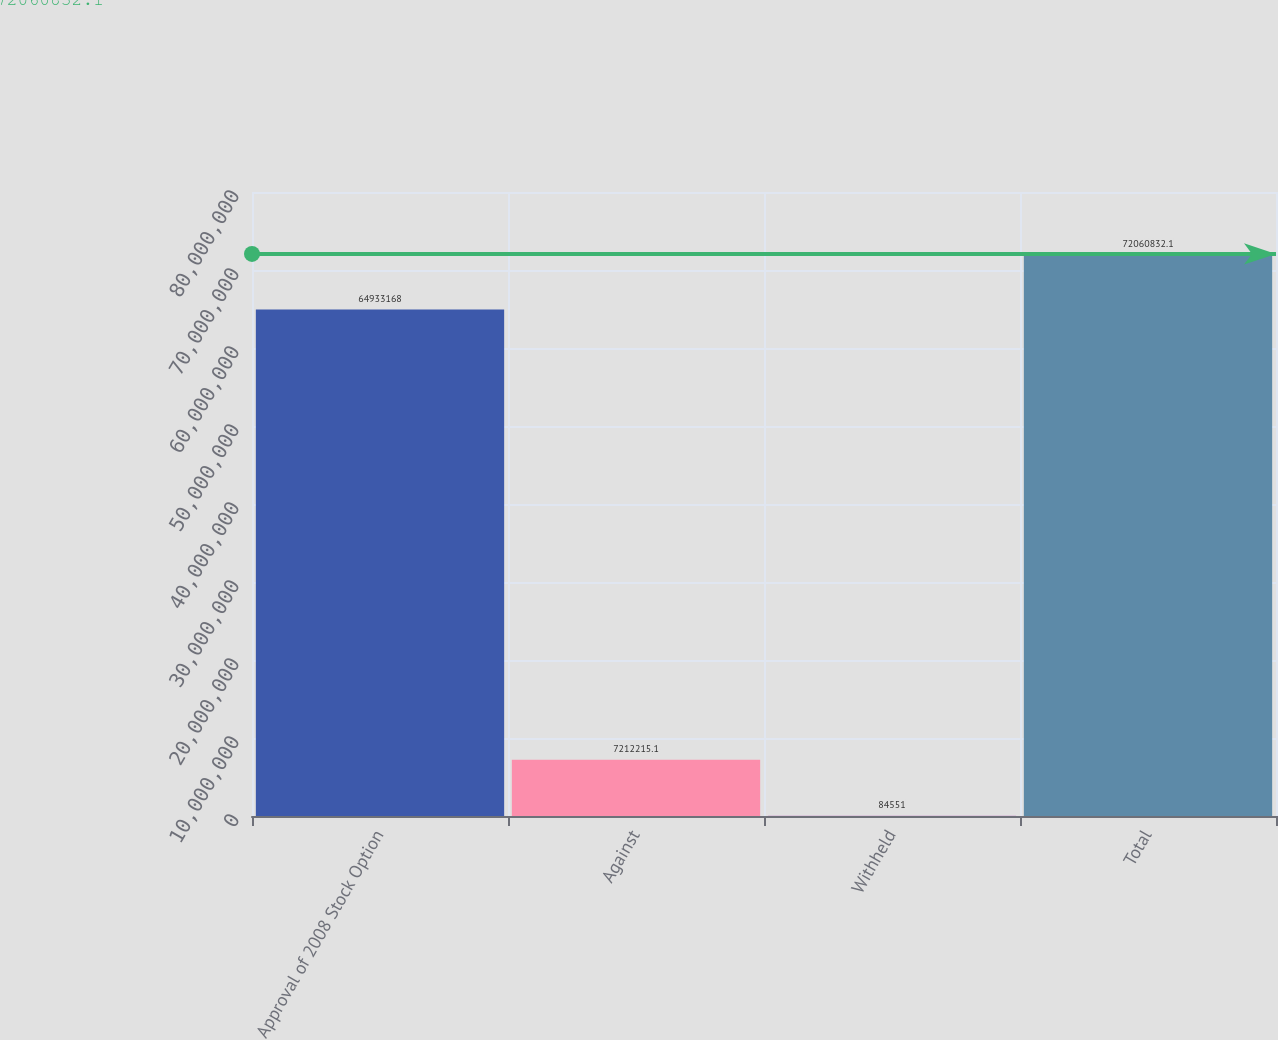<chart> <loc_0><loc_0><loc_500><loc_500><bar_chart><fcel>Approval of 2008 Stock Option<fcel>Against<fcel>Withheld<fcel>Total<nl><fcel>6.49332e+07<fcel>7.21222e+06<fcel>84551<fcel>7.20608e+07<nl></chart> 